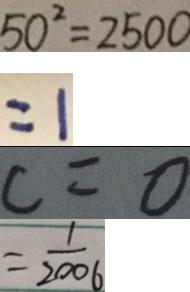<formula> <loc_0><loc_0><loc_500><loc_500>5 0 ^ { 2 } = 2 5 0 0 
 = 1 
 c = 0 
 = \frac { 1 } { 2 0 0 6 }</formula> 